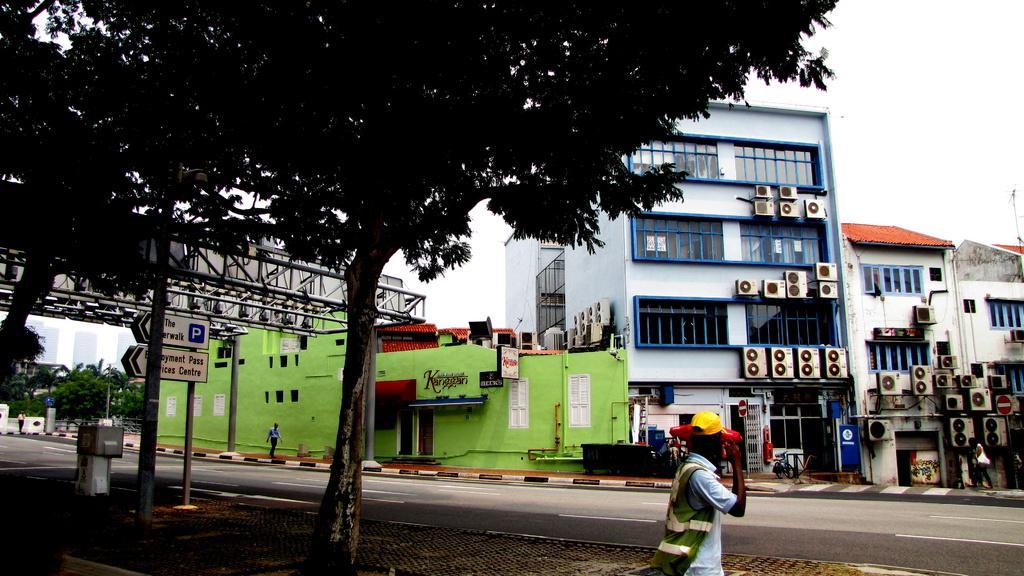In one or two sentences, can you explain what this image depicts? In this image I can see some people on the road, beside the road there are some trees, building and also there are some AC's fit on the buildings. 